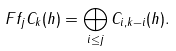Convert formula to latex. <formula><loc_0><loc_0><loc_500><loc_500>\ F f _ { j } C _ { k } ( h ) = \bigoplus _ { i \leq j } C _ { i , k - i } ( h ) .</formula> 